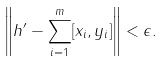<formula> <loc_0><loc_0><loc_500><loc_500>\left \| h ^ { \prime } - \sum _ { i = 1 } ^ { m } [ x _ { i } , y _ { i } ] \right \| < \epsilon .</formula> 